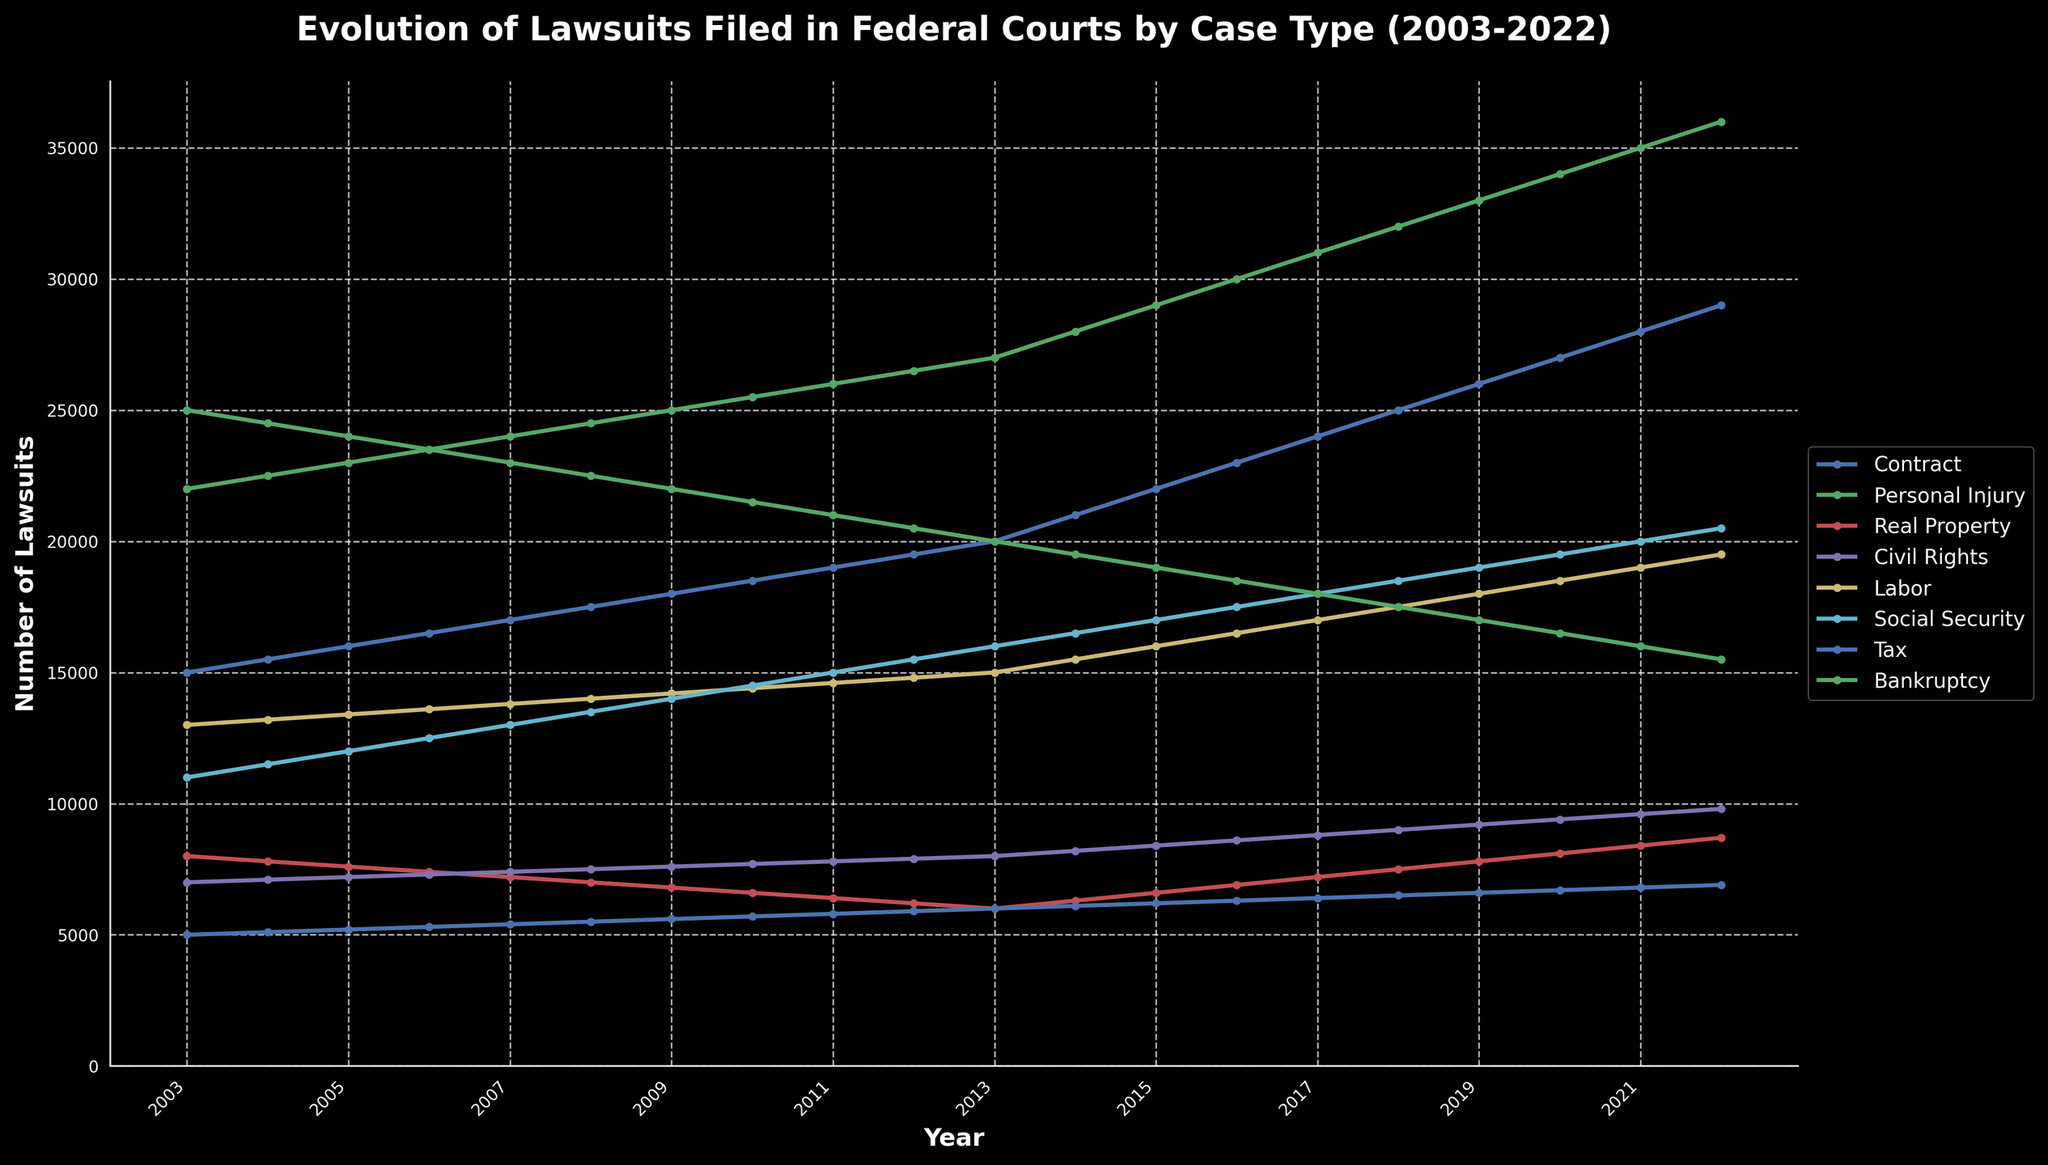What is the title of the figure? The title of the figure is often displayed prominently at the top. In this case, the title should be checked for clarity.
Answer: Evolution of Lawsuits Filed in Federal Courts by Case Type (2003-2022) What is the x-axis label and what does it represent? The x-axis label is typically located below the x-axis and indicates what the horizontal axis represents.
Answer: Year What case type has the highest number of lawsuits filed in 2003? To answer this, locate the data for 2003 on the x-axis and compare the y-values for each case type to determine which is highest.
Answer: Bankruptcy Which case type has shown a steady increase in the number of lawsuits from 2003 to 2022? Observing the trends for each case type, we can see that the lines for some case types exhibit a steady upward trend.
Answer: Labor By how much did the number of Social Security lawsuits increase between 2003 and 2022? Look at the data points for Social Security in 2003 and 2022 and calculate the difference. The number in 2003 is 11,000, and in 2022 it's 20,500. Thus, the increase is 20,500 - 11,000 = 9,500.
Answer: 9,500 Which year witnessed the highest number of Civil Rights lawsuits filed? Find the peak point on the line corresponding to Civil Rights. The highest y-value for Civil Rights is observed at 2022.
Answer: 2022 Comparing the number of Personal Injury lawsuits in 2010 and 2020, which year had fewer lawsuits? Compare the y-values for Personal Injury in 2010 and 2020. In 2010, there were 25,500, and in 2020 there were 34,000. Thus, 2010 had fewer.
Answer: 2010 How did the number of Tax lawsuits evolve from 2003 to 2022? Observe the Tax line from 2003 to 2022. Note if it is generally increasing, decreasing, or staying constant. The trend is consistently increasing from 5,000 in 2003 to 6,900 in 2022.
Answer: Increasing What is the approximate average number of Real Property lawsuits filed over the 20-year period? To find the average, sum the y-values for Real Property from 2003 to 2022 and divide by the number of years (20). The total number of lawsuits is 148,300 (the sum of all the given data points), so the average is 148,300 / 20 = 7,415.
Answer: 7,415 